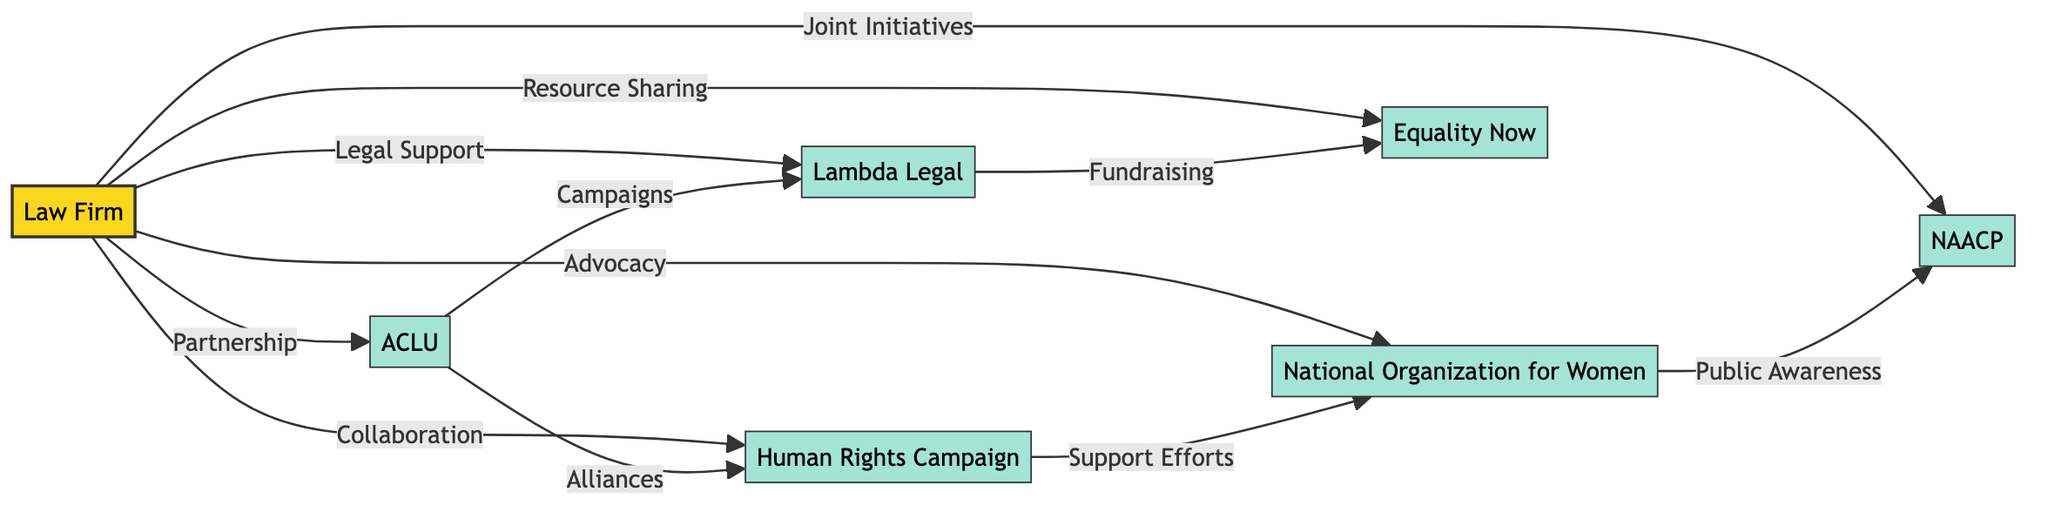What is the total number of nodes in the diagram? The diagram lists all entities involved in the network. By counting the entries in the "nodes" array, we can determine that there are 7 nodes: the Law Firm, ACLU, Human Rights Campaign, Lambda Legal, National Organization for Women, Equality Now, and NAACP.
Answer: 7 Which organization is directly connected to the Law Firm through a Legal Support relationship? The diagram indicates a direct relationship type between nodes. Looking specifically at the relationship that has "Legal Support" as its type leads us to Lambda Legal, which is the organization connected to the Law Firm.
Answer: Lambda Legal What type of relationship exists between the ACLU and Human Rights Campaign? By examining the connection between these two nodes, we see that the arrow originating from the ACLU towards the Human Rights Campaign is labeled "Alliances." This indicates the specific type of relationship they have.
Answer: Alliances Which organization is involved in Joint Initiatives with the Law Firm? The directed arrow leading from the Law Firm provides specific types of relationships. The label on the arrow pointing to NAACP indicates that they collaborate through Joint Initiatives with the Law Firm.
Answer: NAACP Which partnership involves Public Awareness? Referring to the outgoing connection from the National Organization for Women, it leads to the NAACP and is labeled "Public Awareness." This indicates that this specific organization is involved in that type of partnership.
Answer: National Organization for Women How many types of relationships does the Law Firm have with other organizations? Evaluating the links from the law firm, we observe different partnership types: Partnership, Collaboration, Legal Support, Advocacy, Resource Sharing, and Joint Initiatives. Counting these distinct relationship types gives a total of 6.
Answer: 6 Which organization does Lambda Legal connect to through Fundraising? Tracing the directed graph from Lambda Legal, we find a link pointing to Equality Now with "Fundraising" as the connection type. This means that Lambda Legal is involved in Fundraising with Equality Now.
Answer: Equality Now What is the connection type between the Human Rights Campaign and the National Organization for Women? The directed connection from the Human Rights Campaign to the National Organization for Women indicates "Support Efforts," identifying the specific collaborative relationship established between these two entities.
Answer: Support Efforts What is the main role of the Law Firm in this network? By observing the Law Firm's numerous connections to various organizations with different relationship types, it can be stated that its role is central in partnerships and collaborative efforts, facilitating multiple initiatives as evidenced by its various outgoing relationships.
Answer: Central Partner 